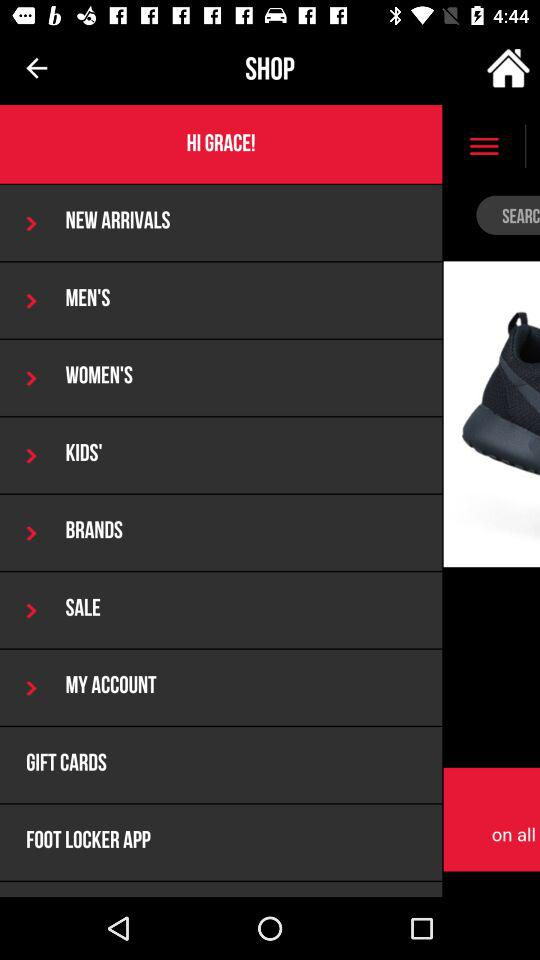What is the day on December 6, 2016? December 6, 2016 is a Tuesday. 